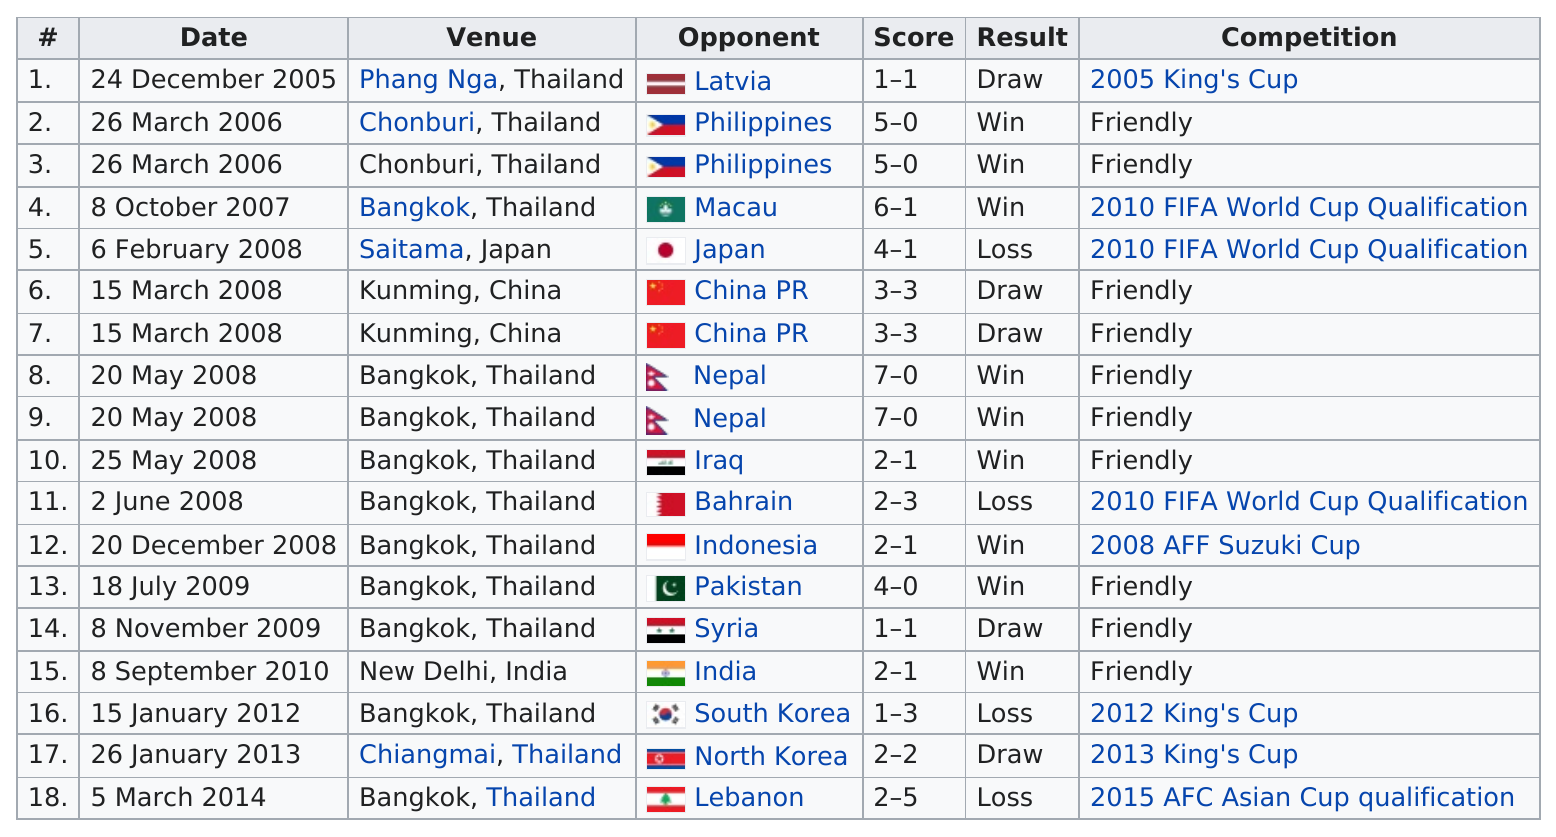Give some essential details in this illustration. There were six winning scores that were at least 3. Of the international goals that Teeratep Winothai made, 4 were not in Thailand. The first international goal was scored on December 24, 2005. After 4 years without a win, the team was in dire need of a victory. The total number of wins for Macau is 6. 